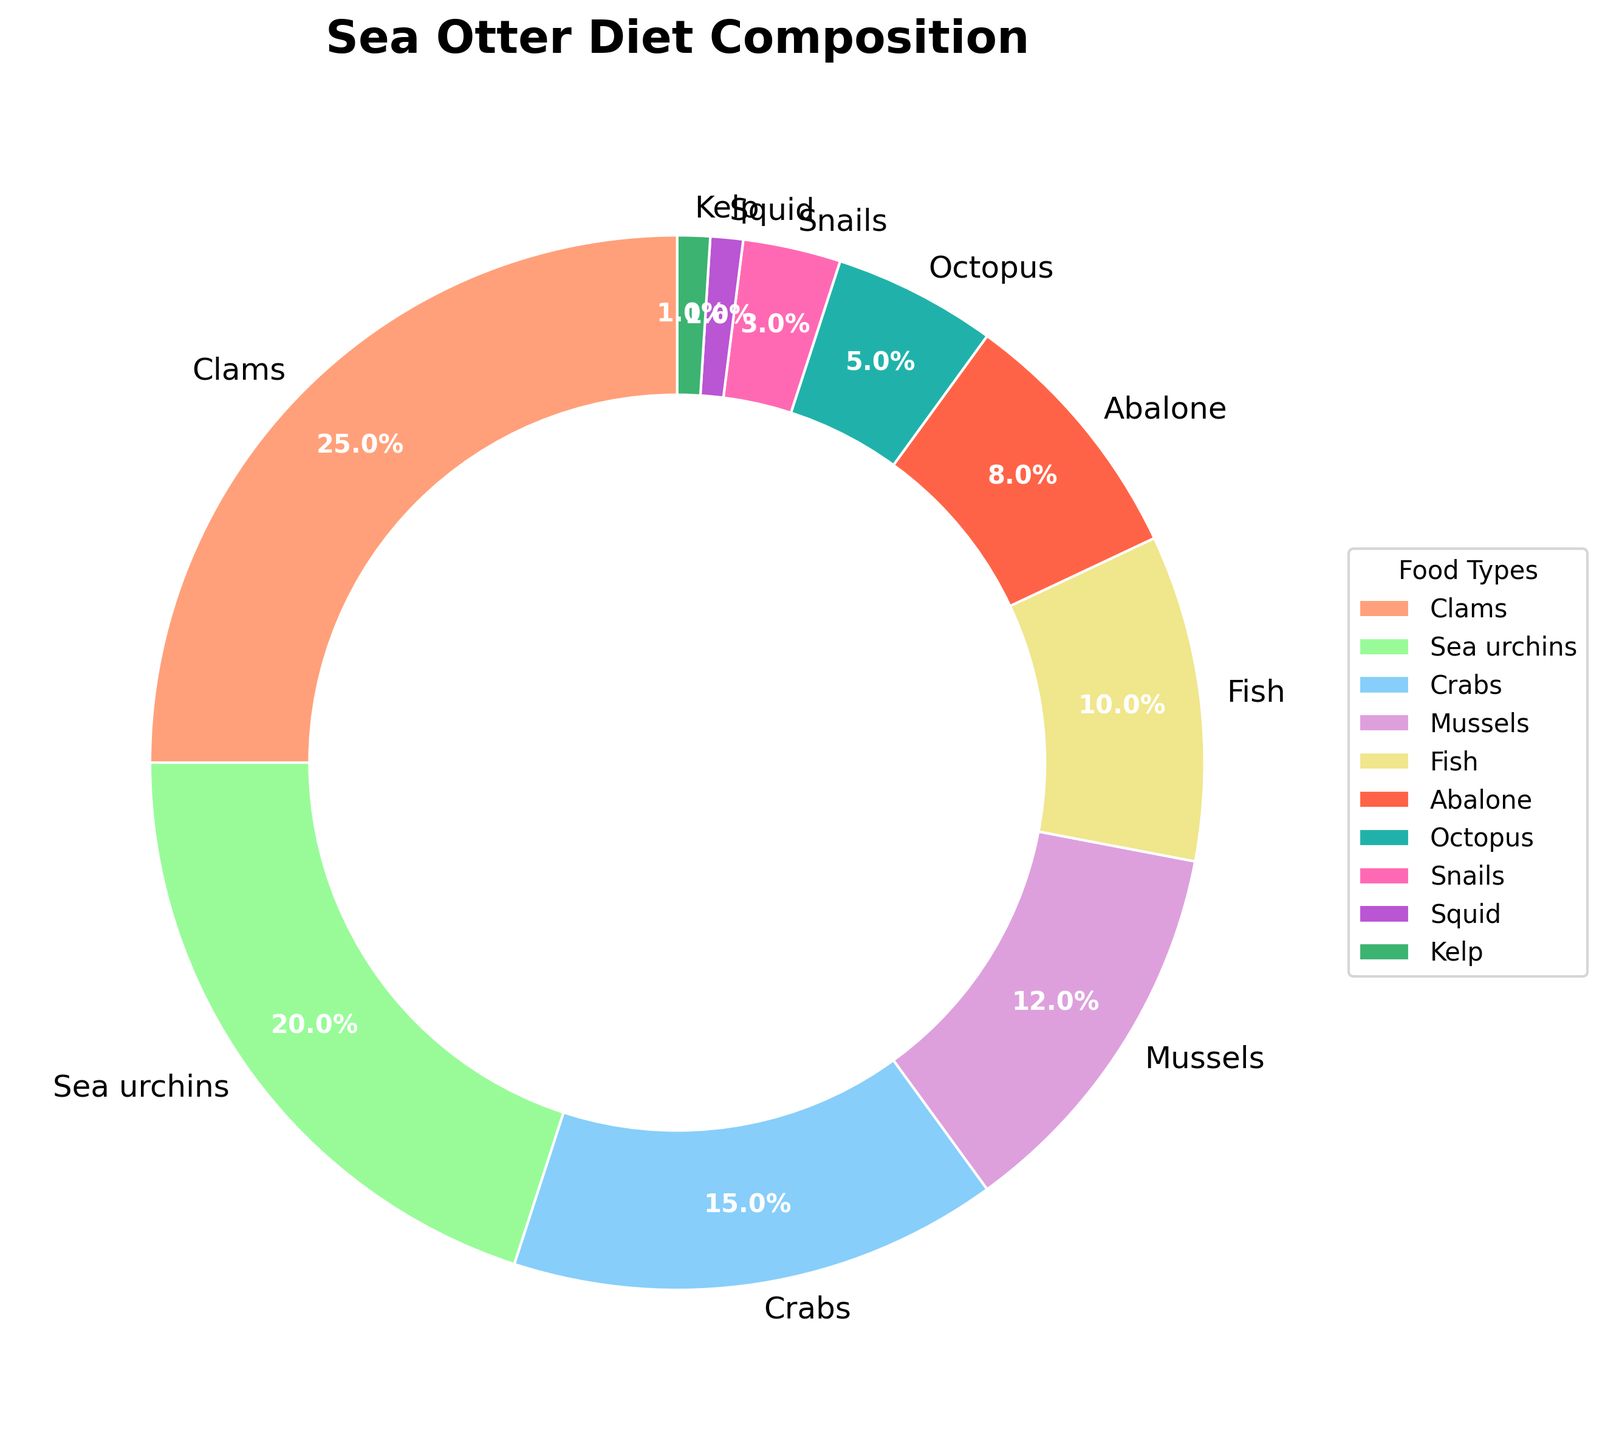Which food type occupies the largest portion of the sea otter diet? The food type with the highest percentage segment in the pie chart represents the largest portion. The largest segment is for Clams.
Answer: Clams Which two food types together make up less than 10% of the sea otter's diet? By looking at the smallest segments, we find Squid (1%) and Kelp (1%). Summing these: 1% + 1% = 2%, which is less than 10%.
Answer: Squid and Kelp How much more of the sea otter's diet is composed of Crabs compared to Abalone? Crabs have a percentage of 15%, and Abalone has 8%. The difference is calculated by 15% - 8% = 7%.
Answer: 7% Which of the food types has a percentage closest to but not exceeding 10%? By checking the percentages in the data, Fish is at exactly 10%. The next highest values are Mussels (12%) and Abalone (8%). So, Fish is closest to but not exceeding.
Answer: Fish What is the combined percentage of the sea otter diet made up of Clams, Sea Urchins, and Crabs? Clams (25%), Sea Urchins (20%), and Crabs (15%). Adding these values: 25% + 20% + 15% = 60%.
Answer: 60% Which food type has a visually smaller portion than Fish but larger than Snails? Among the food types, Octopus (5%) fits as it is smaller than Fish (10%) but larger than Snails (3%).
Answer: Octopus Is the percentage of Mussels greater than Crabs but less than Clams? Mussels are 12%, Crabs are 15%, and Clams are 25%. 15% (Crabs) > 12% (Mussels) > 25% (Clams) is not true. Therefore, Mussels is not greater than Crabs but is less than Clams.
Answer: No How much of the sea otter's diet is made up of food types that are less than 5% each? Snails (3%), Squid (1%), Kelp (1%). Summing these: 3% + 1% + 1% = 5%.
Answer: 5% What is the total percentage of non-crustacean food types in the diet? Crustacean food types include Crabs (15%) and Snails (3%). Total non-crustaceans = 100% - (15% + 3%) = 100% - 18% = 82%.
Answer: 82% 